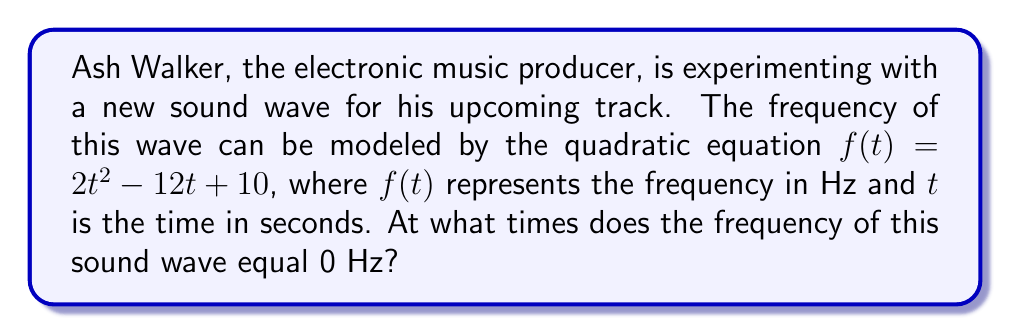Can you answer this question? To find the times when the frequency equals 0 Hz, we need to solve the quadratic equation:

$$2t^2 - 12t + 10 = 0$$

We can solve this using the quadratic formula: $t = \frac{-b \pm \sqrt{b^2 - 4ac}}{2a}$

Where $a = 2$, $b = -12$, and $c = 10$

1) First, let's calculate the discriminant:
   $$b^2 - 4ac = (-12)^2 - 4(2)(10) = 144 - 80 = 64$$

2) Now we can plug this into the quadratic formula:
   $$t = \frac{12 \pm \sqrt{64}}{2(2)} = \frac{12 \pm 8}{4}$$

3) This gives us two solutions:
   $$t_1 = \frac{12 + 8}{4} = \frac{20}{4} = 5$$
   $$t_2 = \frac{12 - 8}{4} = \frac{4}{4} = 1$$

Therefore, the frequency of the sound wave equals 0 Hz at $t = 1$ second and $t = 5$ seconds.
Answer: The roots of the quadratic equation are $t = 1$ and $t = 5$. The frequency of the sound wave equals 0 Hz at 1 second and 5 seconds. 